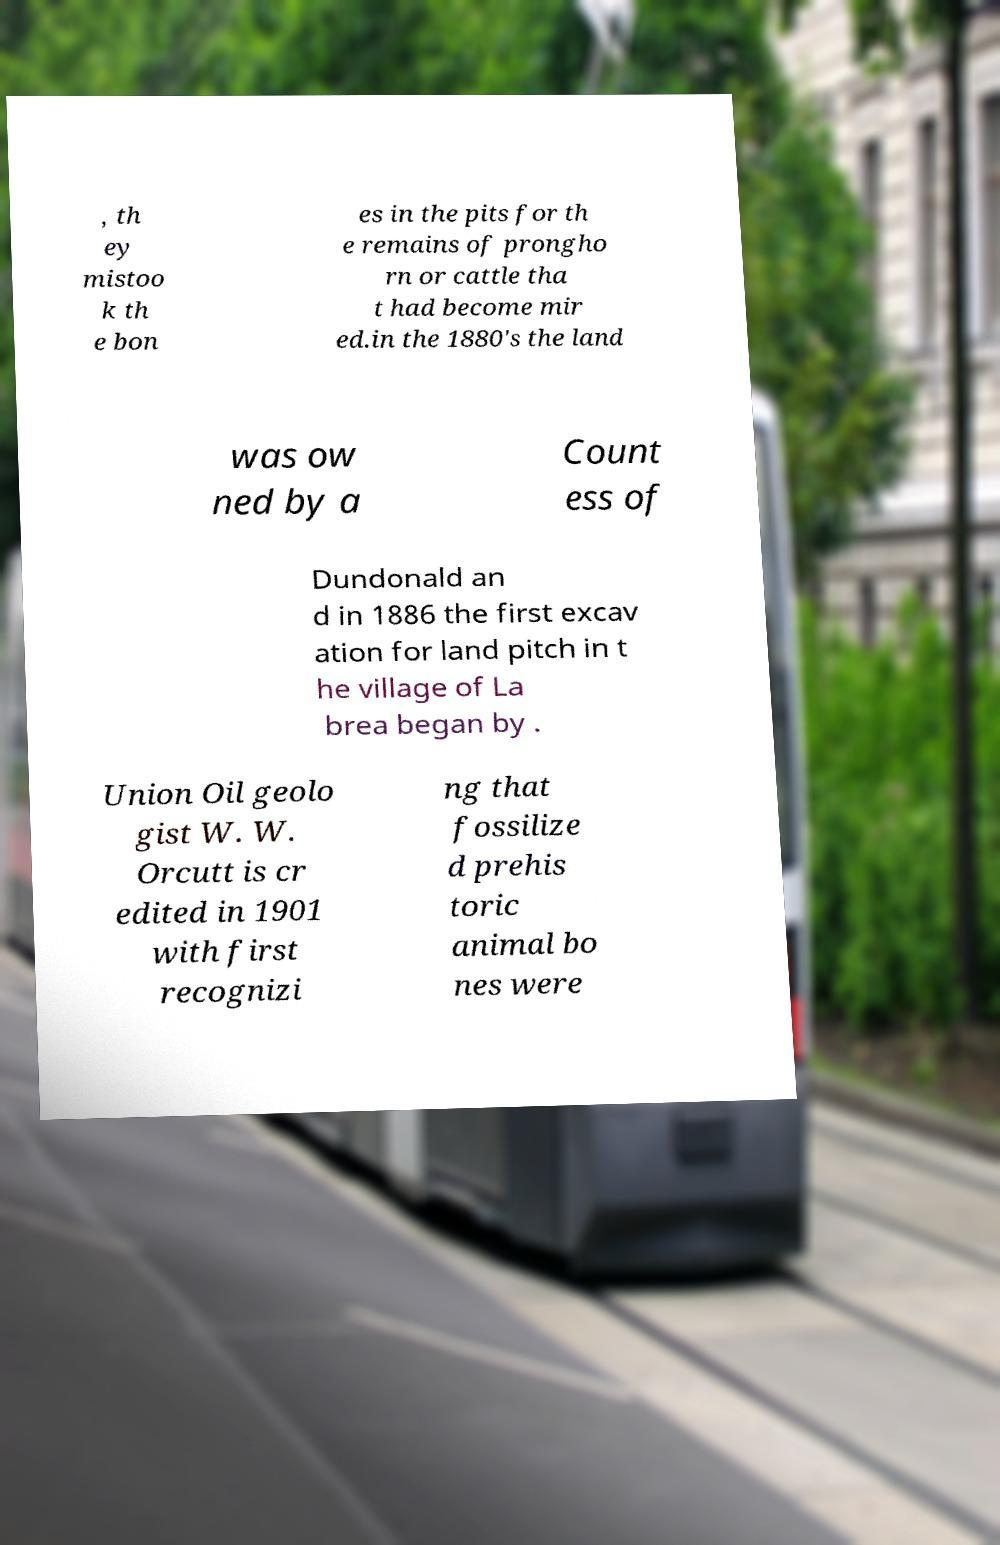Can you read and provide the text displayed in the image?This photo seems to have some interesting text. Can you extract and type it out for me? , th ey mistoo k th e bon es in the pits for th e remains of prongho rn or cattle tha t had become mir ed.in the 1880's the land was ow ned by a Count ess of Dundonald an d in 1886 the first excav ation for land pitch in t he village of La brea began by . Union Oil geolo gist W. W. Orcutt is cr edited in 1901 with first recognizi ng that fossilize d prehis toric animal bo nes were 